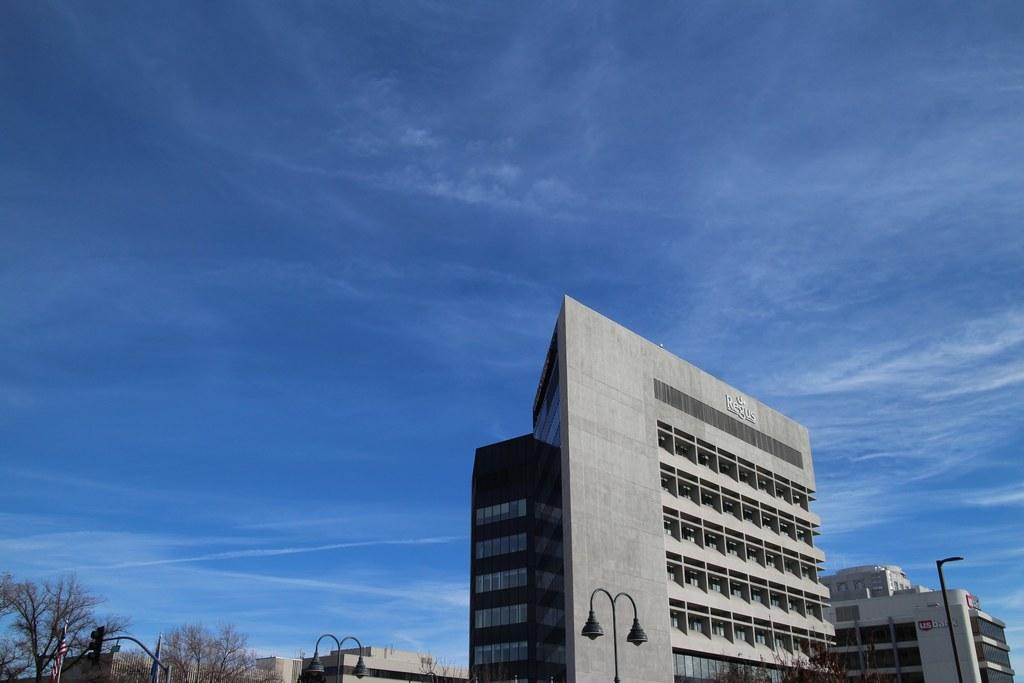What type of structures can be seen in the image? There are buildings in the image. What feature is visible on the buildings? There are windows visible in the image. What type of vegetation is present in the image? There are trees in the image. What type of street furniture can be seen in the image? There are light poles in the image. What symbol is present in the image? There is a flag in the image. What colors can be seen in the sky in the image? The sky is white and blue in color. How many fish can be seen swimming in the image? There are no fish present in the image. What type of tin is being used to hold the trucks in the image? There are no trucks or tin present in the image. 